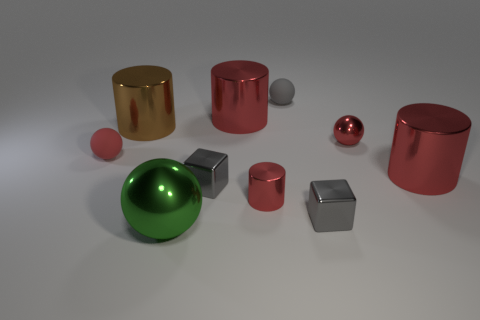Subtract all yellow balls. How many red cylinders are left? 3 Subtract 1 spheres. How many spheres are left? 3 Subtract all balls. How many objects are left? 6 Add 4 small red metal cylinders. How many small red metal cylinders exist? 5 Subtract 0 yellow cylinders. How many objects are left? 10 Subtract all small gray objects. Subtract all gray blocks. How many objects are left? 5 Add 8 blocks. How many blocks are left? 10 